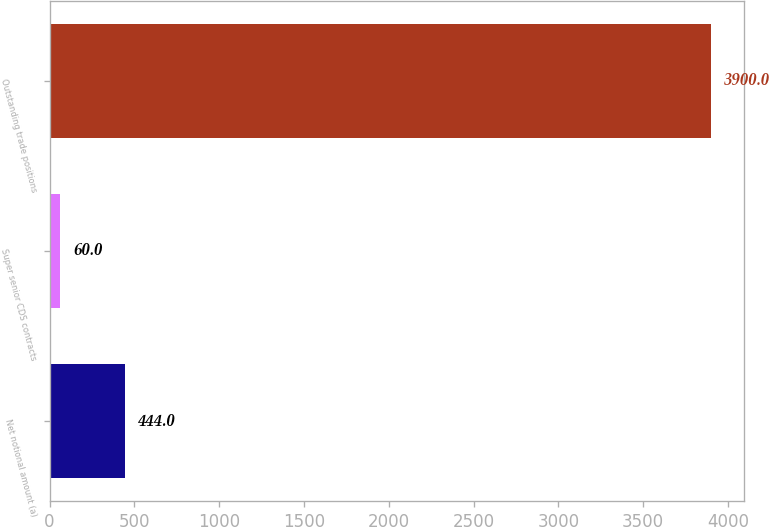Convert chart. <chart><loc_0><loc_0><loc_500><loc_500><bar_chart><fcel>Net notional amount (a)<fcel>Super senior CDS contracts<fcel>Outstanding trade positions<nl><fcel>444<fcel>60<fcel>3900<nl></chart> 